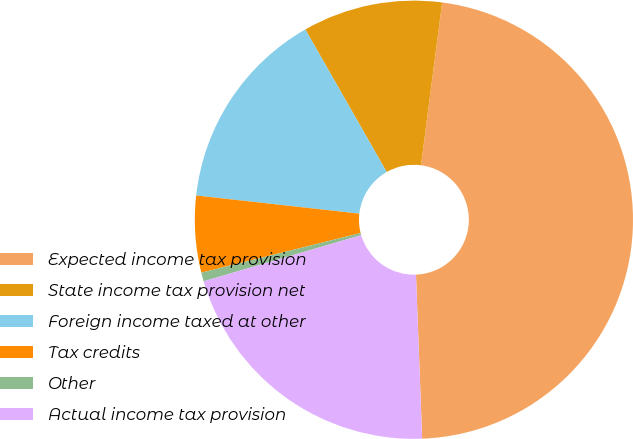Convert chart to OTSL. <chart><loc_0><loc_0><loc_500><loc_500><pie_chart><fcel>Expected income tax provision<fcel>State income tax provision net<fcel>Foreign income taxed at other<fcel>Tax credits<fcel>Other<fcel>Actual income tax provision<nl><fcel>47.34%<fcel>10.31%<fcel>14.98%<fcel>5.65%<fcel>0.65%<fcel>21.06%<nl></chart> 